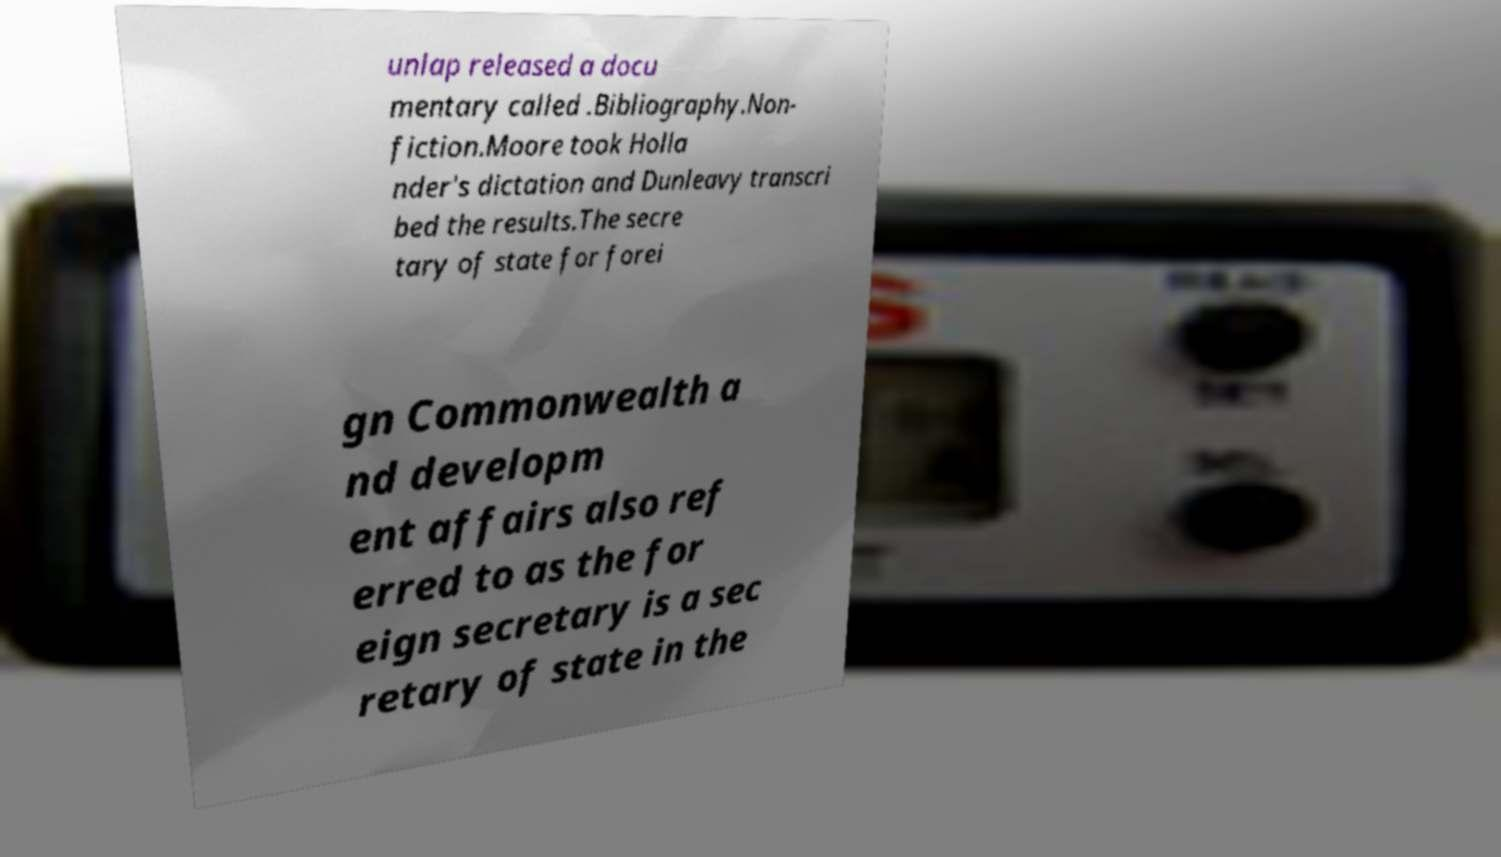Could you extract and type out the text from this image? unlap released a docu mentary called .Bibliography.Non- fiction.Moore took Holla nder's dictation and Dunleavy transcri bed the results.The secre tary of state for forei gn Commonwealth a nd developm ent affairs also ref erred to as the for eign secretary is a sec retary of state in the 